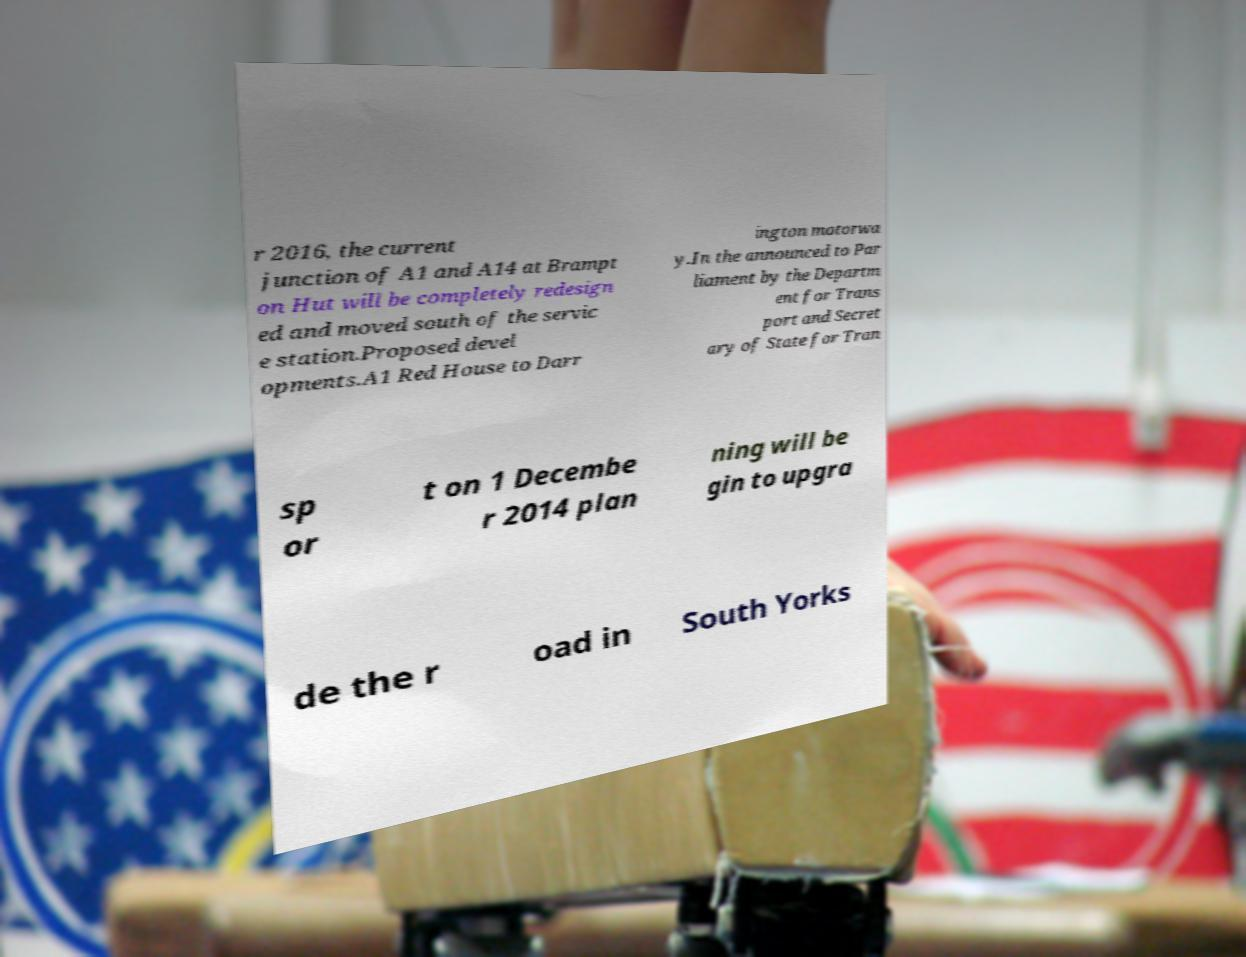I need the written content from this picture converted into text. Can you do that? r 2016, the current junction of A1 and A14 at Brampt on Hut will be completely redesign ed and moved south of the servic e station.Proposed devel opments.A1 Red House to Darr ington motorwa y.In the announced to Par liament by the Departm ent for Trans port and Secret ary of State for Tran sp or t on 1 Decembe r 2014 plan ning will be gin to upgra de the r oad in South Yorks 